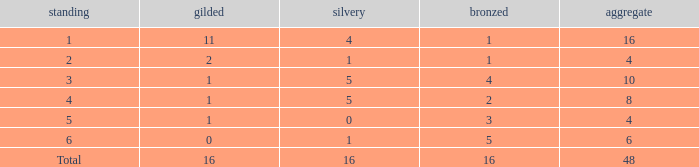How many total gold are less than 4? 0.0. 